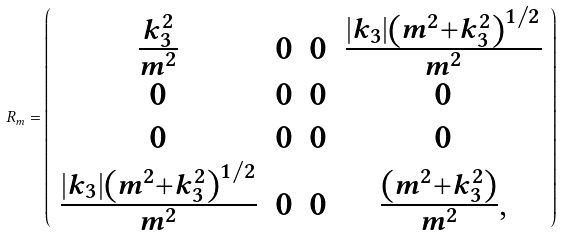Convert formula to latex. <formula><loc_0><loc_0><loc_500><loc_500>R _ { m } = \left ( \begin{array} { c c c c } { { \frac { k _ { 3 } ^ { 2 } } { m ^ { 2 } } } } & { 0 } & { 0 } & { { \frac { \left | k _ { 3 } \right | \left ( m ^ { 2 } + k _ { 3 } ^ { 2 } \right ) ^ { 1 / 2 } } { m ^ { 2 } } } } \\ { 0 } & { 0 } & { 0 } & { 0 } \\ { 0 } & { 0 } & { 0 } & { 0 } \\ { { \frac { \left | k _ { 3 } \right | \left ( m ^ { 2 } + k _ { 3 } ^ { 2 } \right ) ^ { 1 / 2 } } { m ^ { 2 } } } } & { 0 } & { 0 } & { { \frac { \left ( m ^ { 2 } + k _ { 3 } ^ { 2 } \right ) } { m ^ { 2 } } , } } \end{array} \right )</formula> 